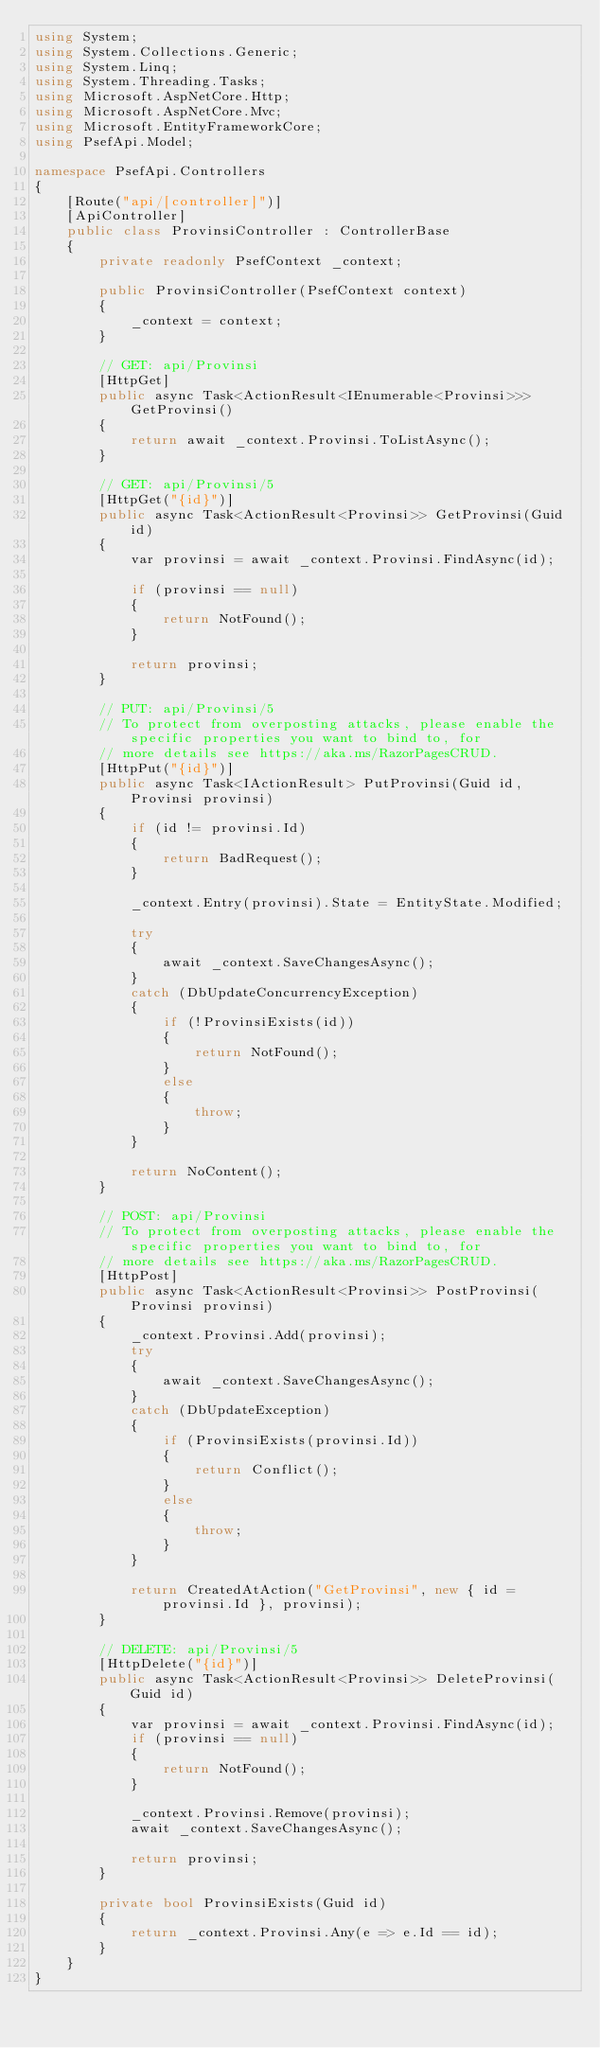<code> <loc_0><loc_0><loc_500><loc_500><_C#_>using System;
using System.Collections.Generic;
using System.Linq;
using System.Threading.Tasks;
using Microsoft.AspNetCore.Http;
using Microsoft.AspNetCore.Mvc;
using Microsoft.EntityFrameworkCore;
using PsefApi.Model;

namespace PsefApi.Controllers
{
    [Route("api/[controller]")]
    [ApiController]
    public class ProvinsiController : ControllerBase
    {
        private readonly PsefContext _context;

        public ProvinsiController(PsefContext context)
        {
            _context = context;
        }

        // GET: api/Provinsi
        [HttpGet]
        public async Task<ActionResult<IEnumerable<Provinsi>>> GetProvinsi()
        {
            return await _context.Provinsi.ToListAsync();
        }

        // GET: api/Provinsi/5
        [HttpGet("{id}")]
        public async Task<ActionResult<Provinsi>> GetProvinsi(Guid id)
        {
            var provinsi = await _context.Provinsi.FindAsync(id);

            if (provinsi == null)
            {
                return NotFound();
            }

            return provinsi;
        }

        // PUT: api/Provinsi/5
        // To protect from overposting attacks, please enable the specific properties you want to bind to, for
        // more details see https://aka.ms/RazorPagesCRUD.
        [HttpPut("{id}")]
        public async Task<IActionResult> PutProvinsi(Guid id, Provinsi provinsi)
        {
            if (id != provinsi.Id)
            {
                return BadRequest();
            }

            _context.Entry(provinsi).State = EntityState.Modified;

            try
            {
                await _context.SaveChangesAsync();
            }
            catch (DbUpdateConcurrencyException)
            {
                if (!ProvinsiExists(id))
                {
                    return NotFound();
                }
                else
                {
                    throw;
                }
            }

            return NoContent();
        }

        // POST: api/Provinsi
        // To protect from overposting attacks, please enable the specific properties you want to bind to, for
        // more details see https://aka.ms/RazorPagesCRUD.
        [HttpPost]
        public async Task<ActionResult<Provinsi>> PostProvinsi(Provinsi provinsi)
        {
            _context.Provinsi.Add(provinsi);
            try
            {
                await _context.SaveChangesAsync();
            }
            catch (DbUpdateException)
            {
                if (ProvinsiExists(provinsi.Id))
                {
                    return Conflict();
                }
                else
                {
                    throw;
                }
            }

            return CreatedAtAction("GetProvinsi", new { id = provinsi.Id }, provinsi);
        }

        // DELETE: api/Provinsi/5
        [HttpDelete("{id}")]
        public async Task<ActionResult<Provinsi>> DeleteProvinsi(Guid id)
        {
            var provinsi = await _context.Provinsi.FindAsync(id);
            if (provinsi == null)
            {
                return NotFound();
            }

            _context.Provinsi.Remove(provinsi);
            await _context.SaveChangesAsync();

            return provinsi;
        }

        private bool ProvinsiExists(Guid id)
        {
            return _context.Provinsi.Any(e => e.Id == id);
        }
    }
}
</code> 